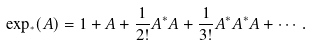<formula> <loc_0><loc_0><loc_500><loc_500>\exp _ { ^ { * } } ( A ) = 1 + A + \frac { 1 } { 2 ! } A ^ { * } A + \frac { 1 } { 3 ! } A ^ { * } A ^ { * } A + \cdots .</formula> 